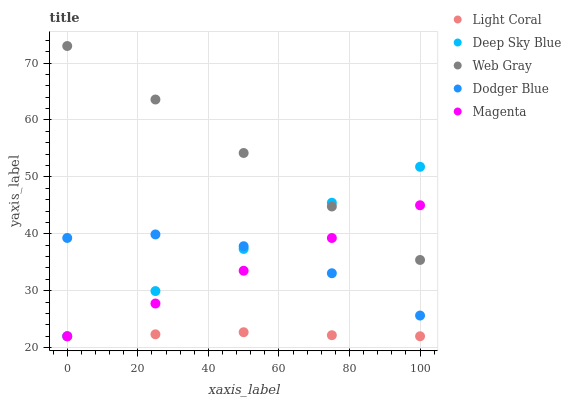Does Light Coral have the minimum area under the curve?
Answer yes or no. Yes. Does Web Gray have the maximum area under the curve?
Answer yes or no. Yes. Does Magenta have the minimum area under the curve?
Answer yes or no. No. Does Magenta have the maximum area under the curve?
Answer yes or no. No. Is Magenta the smoothest?
Answer yes or no. Yes. Is Dodger Blue the roughest?
Answer yes or no. Yes. Is Web Gray the smoothest?
Answer yes or no. No. Is Web Gray the roughest?
Answer yes or no. No. Does Light Coral have the lowest value?
Answer yes or no. Yes. Does Web Gray have the lowest value?
Answer yes or no. No. Does Web Gray have the highest value?
Answer yes or no. Yes. Does Magenta have the highest value?
Answer yes or no. No. Is Light Coral less than Web Gray?
Answer yes or no. Yes. Is Web Gray greater than Dodger Blue?
Answer yes or no. Yes. Does Magenta intersect Deep Sky Blue?
Answer yes or no. Yes. Is Magenta less than Deep Sky Blue?
Answer yes or no. No. Is Magenta greater than Deep Sky Blue?
Answer yes or no. No. Does Light Coral intersect Web Gray?
Answer yes or no. No. 